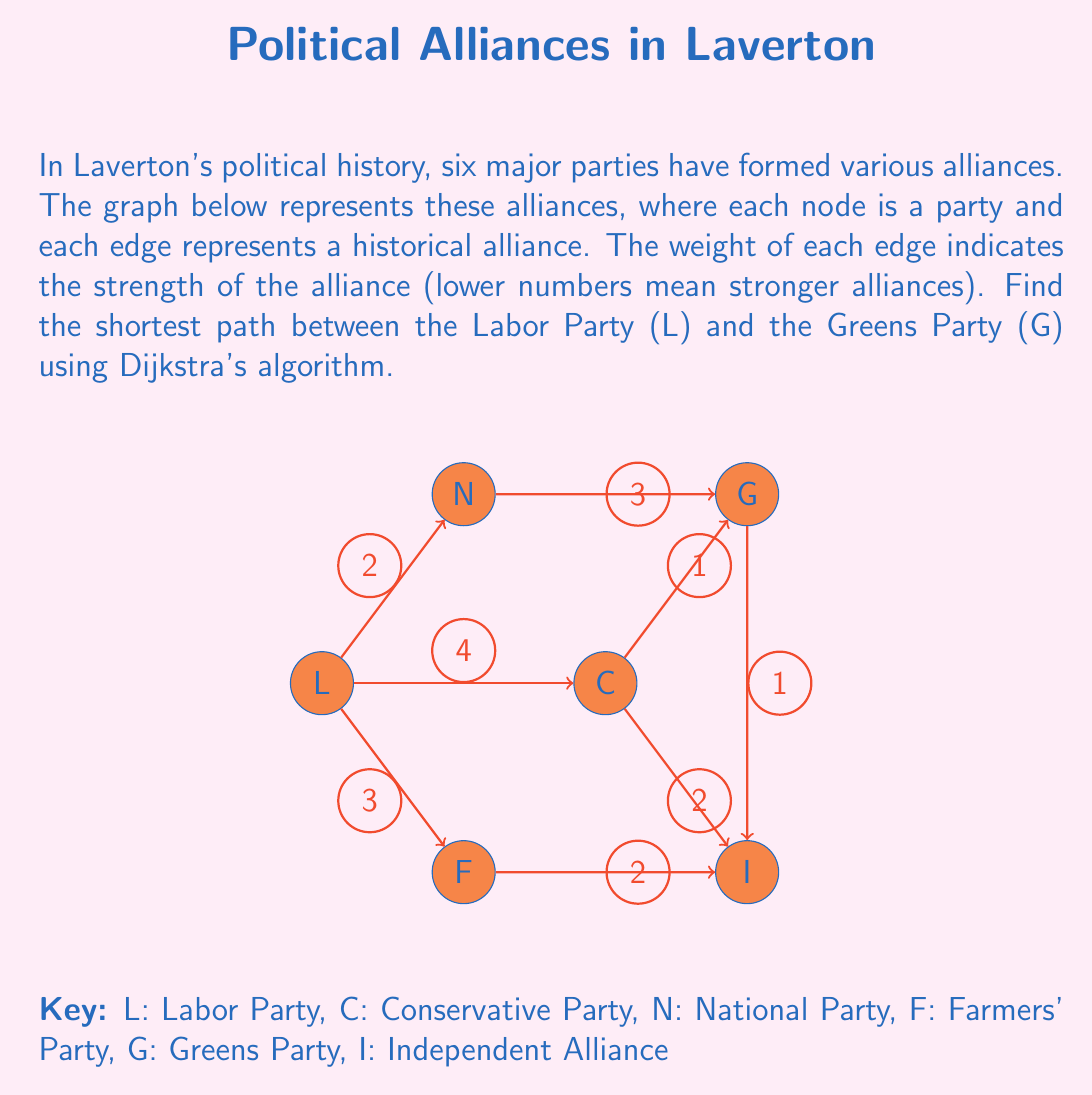Can you answer this question? To solve this problem using Dijkstra's algorithm, we'll follow these steps:

1) Initialize:
   - Set distance to L (start) as 0
   - Set distances to all other nodes as infinity
   - Set all nodes as unvisited

2) For the current node (starting with L), consider all unvisited neighbors and calculate their tentative distances.
   
3) When we're done considering all neighbors of the current node, mark it as visited.

4) If the destination node (G) has been marked visited, we're done.

5) Otherwise, select the unvisited node with the smallest tentative distance and set it as the new current node. Go back to step 2.

Let's apply the algorithm:

1) Initial state:
   L: 0 (current)
   C, N, F, G, I: $\infty$

2) From L:
   C: 4, N: 2, F: 3
   L: 0 (visited)
   C: 4, N: 2, F: 3, G: $\infty$, I: $\infty$

3) From N (smallest unvisited):
   G: 2 + 3 = 5
   N: 2 (visited)
   C: 4, F: 3, G: 5, I: $\infty$

4) From F:
   I: 3 + 2 = 5
   F: 3 (visited)
   C: 4, G: 5, I: 5

5) From C:
   G: min(5, 4 + 1) = 5
   I: min(5, 4 + 2) = 5
   C: 4 (visited)
   G: 5, I: 5

6) G is now the node with the smallest distance, so we're done.

The shortest path is L -> N -> G with a total distance of 5.
Answer: The shortest path from the Labor Party to the Greens Party is Labor -> National -> Greens, with a total alliance strength of 5. 